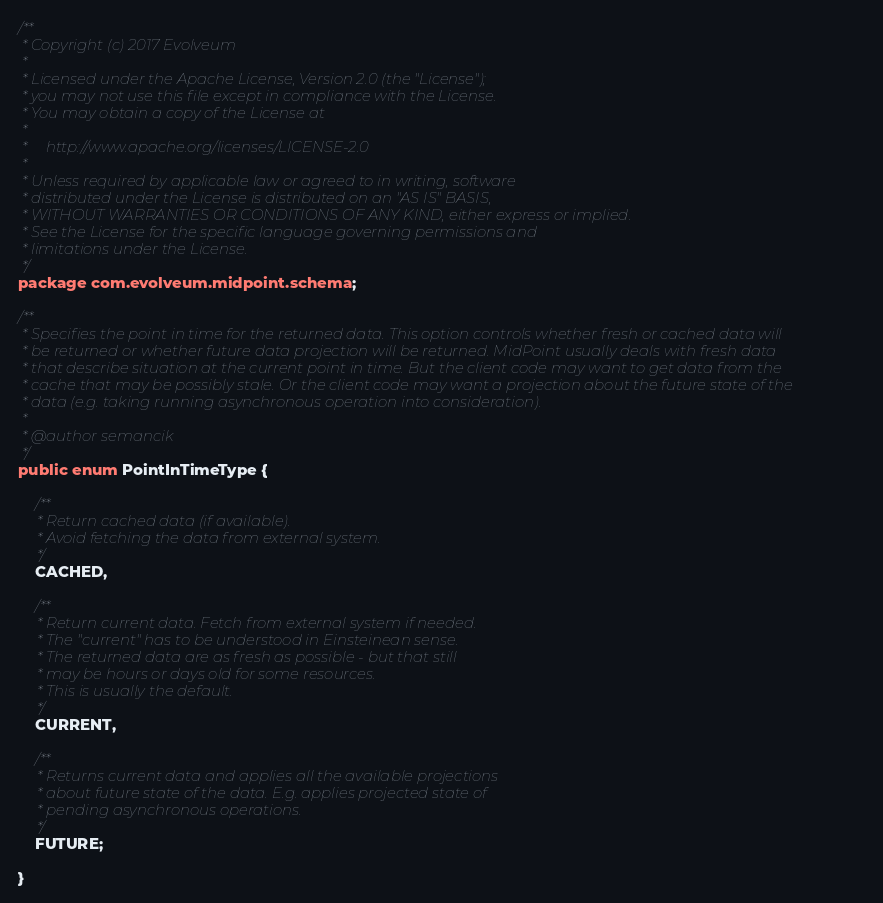Convert code to text. <code><loc_0><loc_0><loc_500><loc_500><_Java_>/**
 * Copyright (c) 2017 Evolveum
 *
 * Licensed under the Apache License, Version 2.0 (the "License");
 * you may not use this file except in compliance with the License.
 * You may obtain a copy of the License at
 *
 *     http://www.apache.org/licenses/LICENSE-2.0
 *
 * Unless required by applicable law or agreed to in writing, software
 * distributed under the License is distributed on an "AS IS" BASIS,
 * WITHOUT WARRANTIES OR CONDITIONS OF ANY KIND, either express or implied.
 * See the License for the specific language governing permissions and
 * limitations under the License.
 */
package com.evolveum.midpoint.schema;

/**
 * Specifies the point in time for the returned data. This option controls whether fresh or cached data will
 * be returned or whether future data projection will be returned. MidPoint usually deals with fresh data
 * that describe situation at the current point in time. But the client code may want to get data from the
 * cache that may be possibly stale. Or the client code may want a projection about the future state of the
 * data (e.g. taking running asynchronous operation into consideration).
 * 
 * @author semancik
 */
public enum PointInTimeType {
	
	/**
	 * Return cached data (if available).
	 * Avoid fetching the data from external system.
	 */
	CACHED,
	
	/**
	 * Return current data. Fetch from external system if needed.
	 * The "current" has to be understood in Einsteinean sense.
	 * The returned data are as fresh as possible - but that still
	 * may be hours or days old for some resources.
	 * This is usually the default. 
	 */
	CURRENT,
	
	/**
	 * Returns current data and applies all the available projections
	 * about future state of the data. E.g. applies projected state of
	 * pending asynchronous operations.
	 */
	FUTURE;

}
</code> 